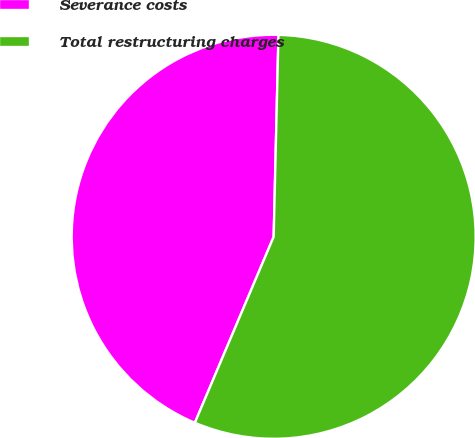Convert chart. <chart><loc_0><loc_0><loc_500><loc_500><pie_chart><fcel>Severance costs<fcel>Total restructuring charges<nl><fcel>44.0%<fcel>56.0%<nl></chart> 